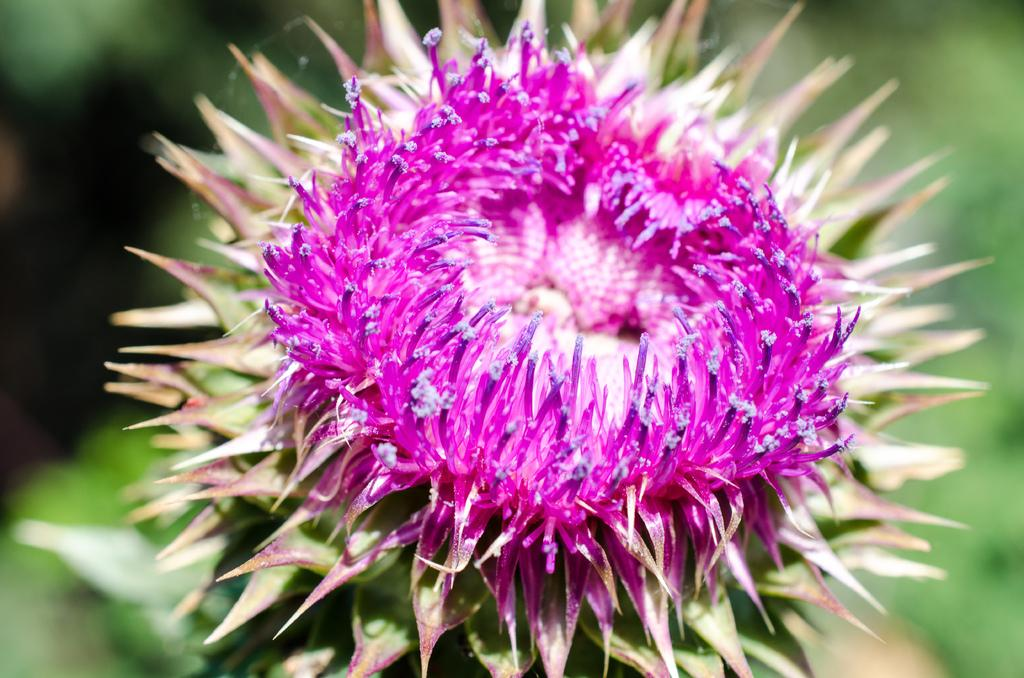What is the main subject of the image? There is a flower in the image. Can you describe the background of the image? The background of the image is blurred. How many oranges are hanging from the flower in the image? There are no oranges present in the image; it features a flower. What direction is the sun shining from in the image? There is no sun visible in the image, so it is not possible to determine the direction of sunlight. 